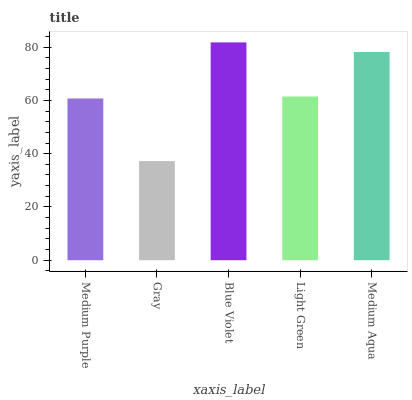Is Gray the minimum?
Answer yes or no. Yes. Is Blue Violet the maximum?
Answer yes or no. Yes. Is Blue Violet the minimum?
Answer yes or no. No. Is Gray the maximum?
Answer yes or no. No. Is Blue Violet greater than Gray?
Answer yes or no. Yes. Is Gray less than Blue Violet?
Answer yes or no. Yes. Is Gray greater than Blue Violet?
Answer yes or no. No. Is Blue Violet less than Gray?
Answer yes or no. No. Is Light Green the high median?
Answer yes or no. Yes. Is Light Green the low median?
Answer yes or no. Yes. Is Medium Aqua the high median?
Answer yes or no. No. Is Medium Aqua the low median?
Answer yes or no. No. 